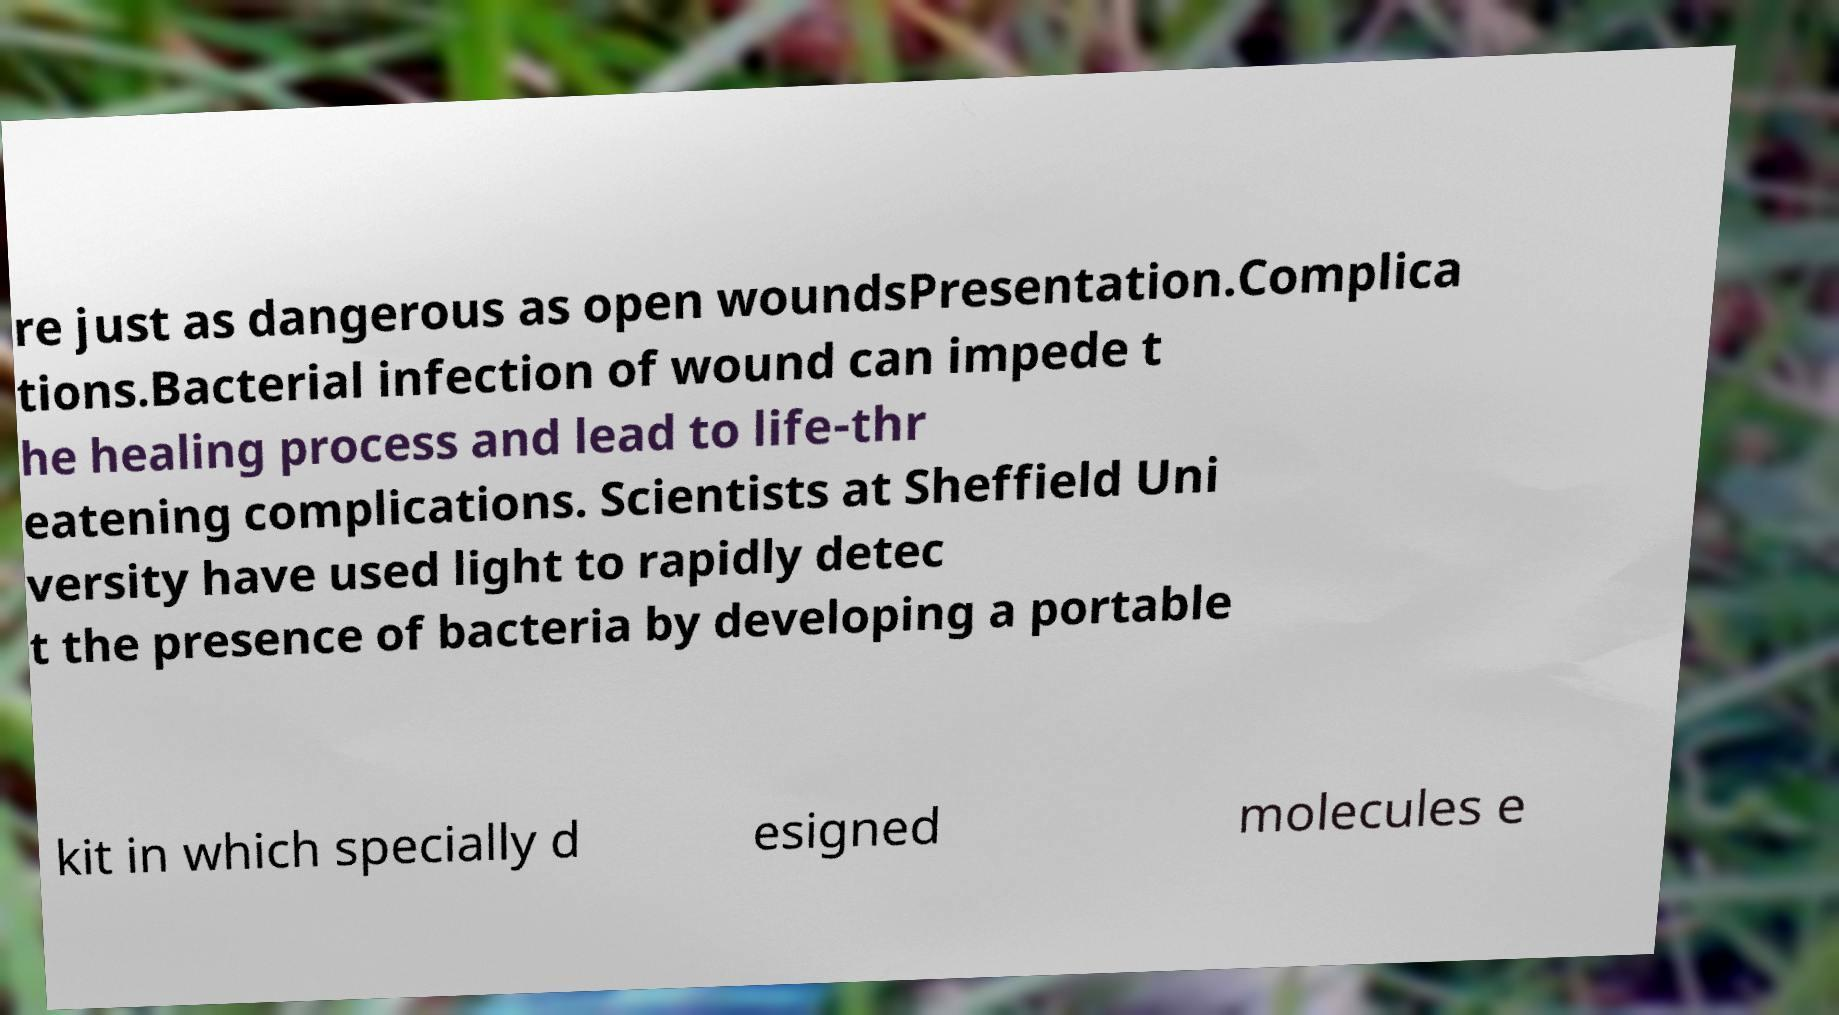For documentation purposes, I need the text within this image transcribed. Could you provide that? re just as dangerous as open woundsPresentation.Complica tions.Bacterial infection of wound can impede t he healing process and lead to life-thr eatening complications. Scientists at Sheffield Uni versity have used light to rapidly detec t the presence of bacteria by developing a portable kit in which specially d esigned molecules e 